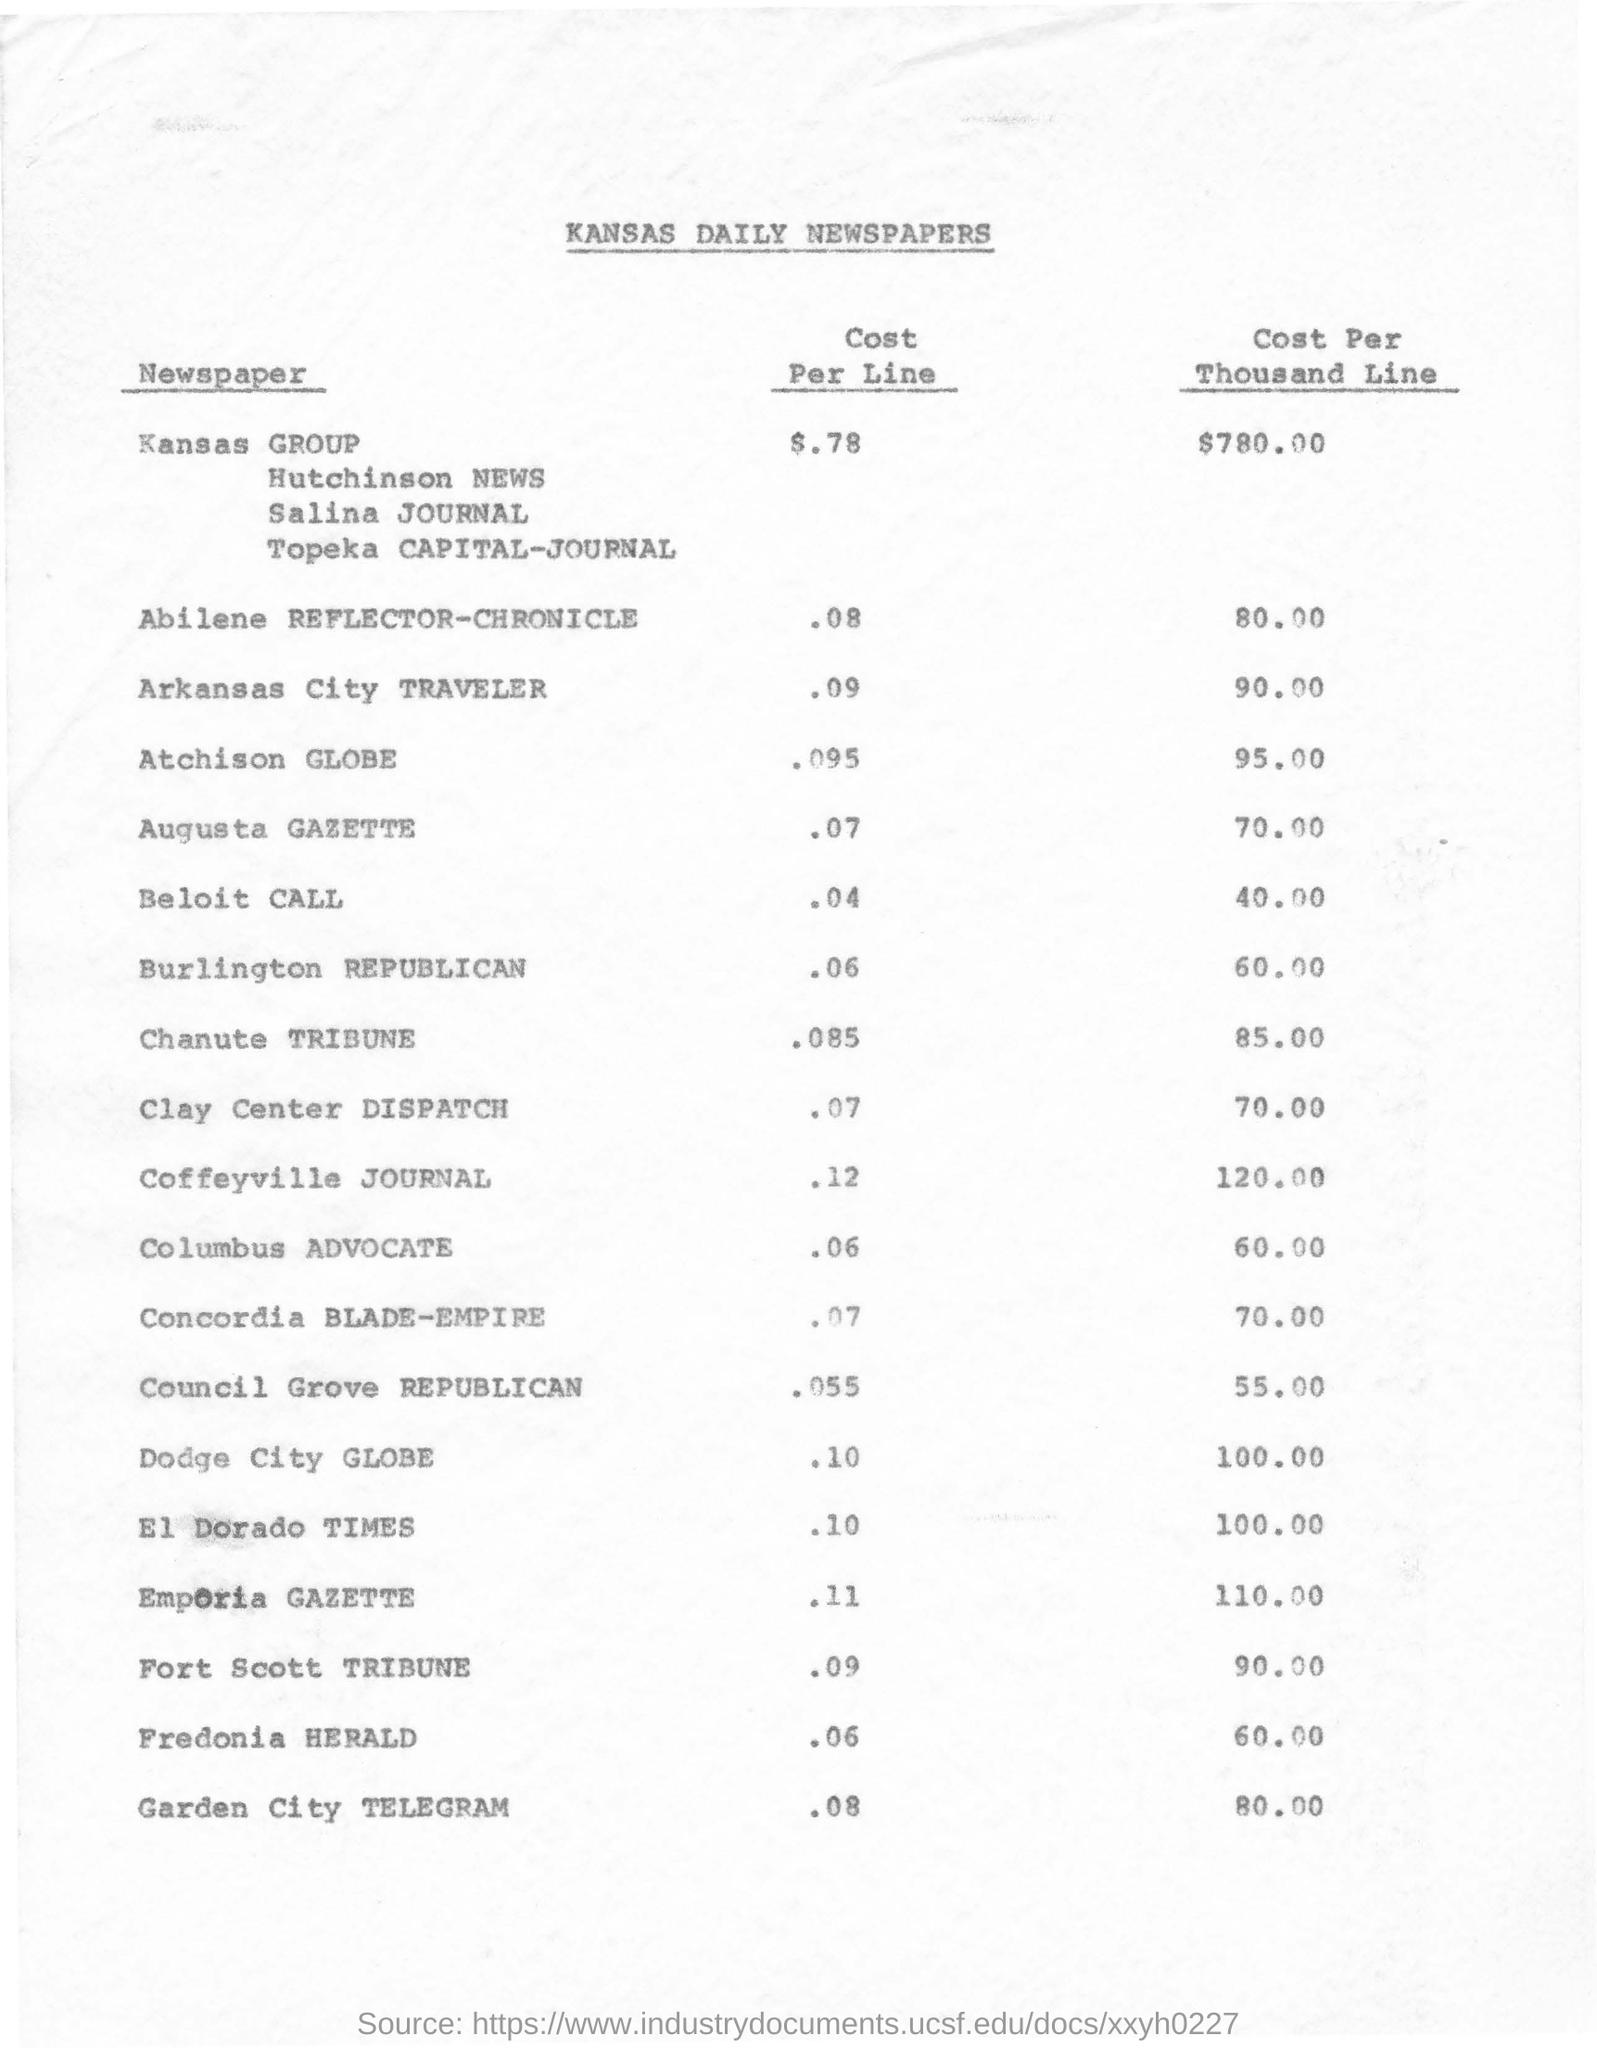Outline some significant characteristics in this image. The headline of this document is 'KANSAS DAILY NEWSPAPERS.' The cost of the Garden City TELEGRAM is $0.80 per thousand lines. 